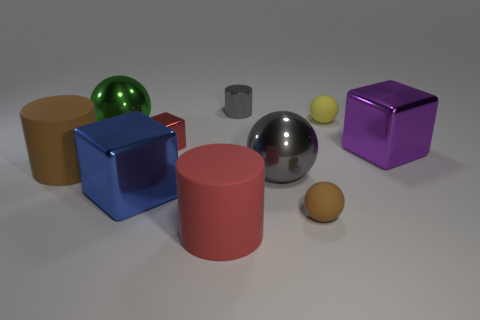There is a sphere that is the same color as the tiny metallic cylinder; what size is it?
Keep it short and to the point. Large. How many other things are there of the same size as the gray sphere?
Your answer should be compact. 5. The metal thing that is right of the big ball in front of the big rubber object to the left of the large red rubber cylinder is what color?
Provide a short and direct response. Purple. How many other things are the same shape as the big red object?
Provide a succinct answer. 2. What shape is the brown rubber thing to the left of the green ball?
Offer a terse response. Cylinder. There is a rubber cylinder that is behind the big blue block; are there any large blocks in front of it?
Provide a succinct answer. Yes. What is the color of the cylinder that is on the right side of the big brown cylinder and behind the red cylinder?
Offer a terse response. Gray. Are there any big metal cubes to the left of the ball on the left side of the cylinder behind the green metal thing?
Make the answer very short. No. What is the size of the brown matte thing that is the same shape as the green shiny thing?
Provide a succinct answer. Small. Are there any other things that have the same material as the big purple thing?
Your answer should be very brief. Yes. 